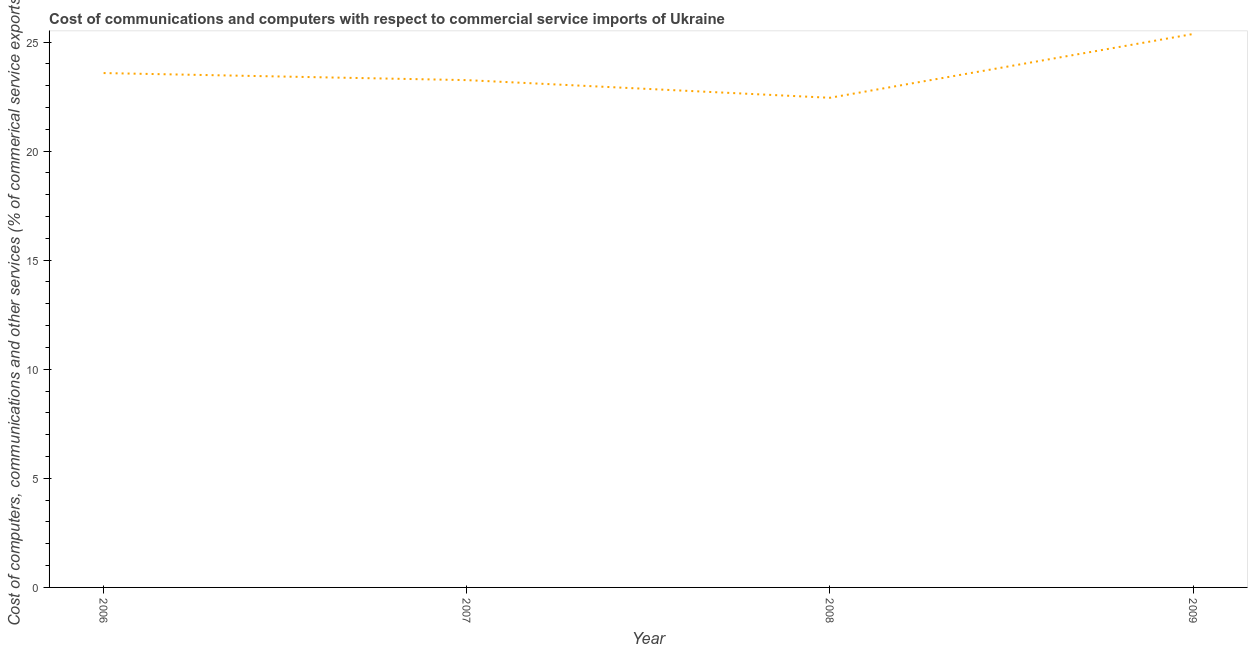What is the cost of communications in 2008?
Ensure brevity in your answer.  22.44. Across all years, what is the maximum cost of communications?
Your answer should be compact. 25.37. Across all years, what is the minimum cost of communications?
Provide a short and direct response. 22.44. What is the sum of the  computer and other services?
Your answer should be very brief. 94.64. What is the difference between the  computer and other services in 2006 and 2007?
Give a very brief answer. 0.32. What is the average cost of communications per year?
Provide a short and direct response. 23.66. What is the median cost of communications?
Provide a short and direct response. 23.41. In how many years, is the cost of communications greater than 21 %?
Make the answer very short. 4. What is the ratio of the  computer and other services in 2008 to that in 2009?
Your answer should be very brief. 0.88. Is the  computer and other services in 2007 less than that in 2009?
Offer a terse response. Yes. What is the difference between the highest and the second highest  computer and other services?
Provide a short and direct response. 1.79. Is the sum of the  computer and other services in 2006 and 2009 greater than the maximum  computer and other services across all years?
Keep it short and to the point. Yes. What is the difference between the highest and the lowest  computer and other services?
Your answer should be compact. 2.92. How many lines are there?
Make the answer very short. 1. What is the difference between two consecutive major ticks on the Y-axis?
Your answer should be compact. 5. Does the graph contain any zero values?
Keep it short and to the point. No. Does the graph contain grids?
Make the answer very short. No. What is the title of the graph?
Make the answer very short. Cost of communications and computers with respect to commercial service imports of Ukraine. What is the label or title of the Y-axis?
Offer a terse response. Cost of computers, communications and other services (% of commerical service exports). What is the Cost of computers, communications and other services (% of commerical service exports) in 2006?
Keep it short and to the point. 23.58. What is the Cost of computers, communications and other services (% of commerical service exports) of 2007?
Provide a short and direct response. 23.25. What is the Cost of computers, communications and other services (% of commerical service exports) in 2008?
Your answer should be very brief. 22.44. What is the Cost of computers, communications and other services (% of commerical service exports) of 2009?
Provide a succinct answer. 25.37. What is the difference between the Cost of computers, communications and other services (% of commerical service exports) in 2006 and 2007?
Your answer should be compact. 0.32. What is the difference between the Cost of computers, communications and other services (% of commerical service exports) in 2006 and 2008?
Provide a succinct answer. 1.13. What is the difference between the Cost of computers, communications and other services (% of commerical service exports) in 2006 and 2009?
Give a very brief answer. -1.79. What is the difference between the Cost of computers, communications and other services (% of commerical service exports) in 2007 and 2008?
Offer a terse response. 0.81. What is the difference between the Cost of computers, communications and other services (% of commerical service exports) in 2007 and 2009?
Keep it short and to the point. -2.11. What is the difference between the Cost of computers, communications and other services (% of commerical service exports) in 2008 and 2009?
Your answer should be compact. -2.92. What is the ratio of the Cost of computers, communications and other services (% of commerical service exports) in 2006 to that in 2008?
Your response must be concise. 1.05. What is the ratio of the Cost of computers, communications and other services (% of commerical service exports) in 2006 to that in 2009?
Keep it short and to the point. 0.93. What is the ratio of the Cost of computers, communications and other services (% of commerical service exports) in 2007 to that in 2008?
Give a very brief answer. 1.04. What is the ratio of the Cost of computers, communications and other services (% of commerical service exports) in 2007 to that in 2009?
Offer a very short reply. 0.92. What is the ratio of the Cost of computers, communications and other services (% of commerical service exports) in 2008 to that in 2009?
Make the answer very short. 0.89. 